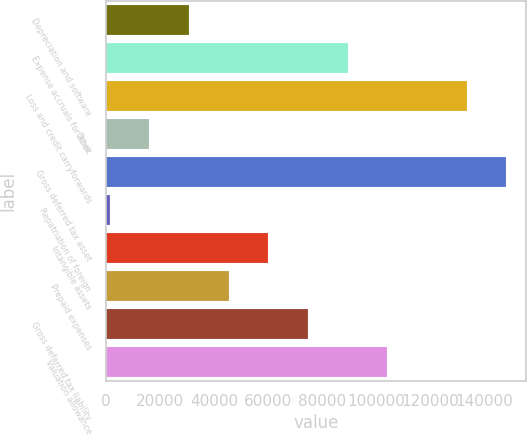Convert chart. <chart><loc_0><loc_0><loc_500><loc_500><bar_chart><fcel>Depreciation and software<fcel>Expense accruals for book<fcel>Loss and credit carryforwards<fcel>Other<fcel>Gross deferred tax asset<fcel>Repatriation of foreign<fcel>Intangible assets<fcel>Prepaid expenses<fcel>Gross deferred tax liability<fcel>Valuation allowance<nl><fcel>30754.4<fcel>89403.2<fcel>133390<fcel>16092.2<fcel>148052<fcel>1430<fcel>60078.8<fcel>45416.6<fcel>74741<fcel>104065<nl></chart> 